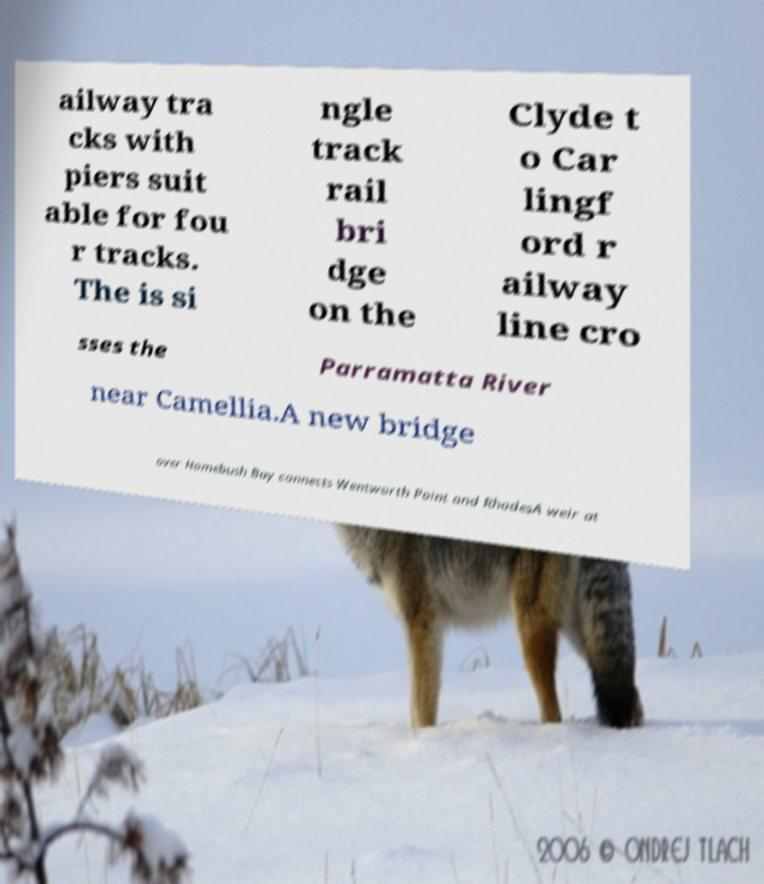There's text embedded in this image that I need extracted. Can you transcribe it verbatim? ailway tra cks with piers suit able for fou r tracks. The is si ngle track rail bri dge on the Clyde t o Car lingf ord r ailway line cro sses the Parramatta River near Camellia.A new bridge over Homebush Bay connects Wentworth Point and RhodesA weir at 